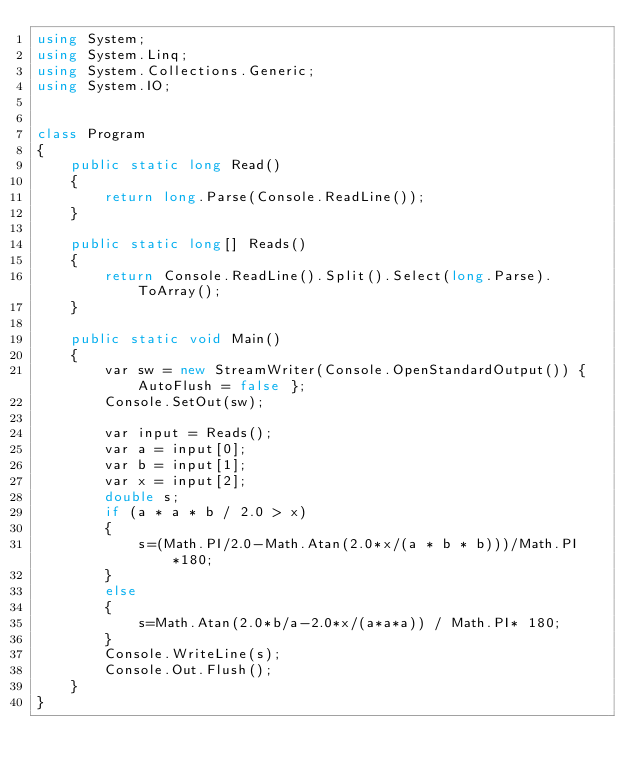Convert code to text. <code><loc_0><loc_0><loc_500><loc_500><_C#_>using System;
using System.Linq;
using System.Collections.Generic;
using System.IO;


class Program
{
    public static long Read()
    {
        return long.Parse(Console.ReadLine());
    }

    public static long[] Reads()
    {
        return Console.ReadLine().Split().Select(long.Parse).ToArray();
    }

    public static void Main()
    {
        var sw = new StreamWriter(Console.OpenStandardOutput()) { AutoFlush = false };
        Console.SetOut(sw);

        var input = Reads();
        var a = input[0];
        var b = input[1];
        var x = input[2];
        double s;
        if (a * a * b / 2.0 > x)
        {
            s=(Math.PI/2.0-Math.Atan(2.0*x/(a * b * b)))/Math.PI*180;
        }
        else
        {
            s=Math.Atan(2.0*b/a-2.0*x/(a*a*a)) / Math.PI* 180;
        }
        Console.WriteLine(s);
        Console.Out.Flush();
    }
}
</code> 